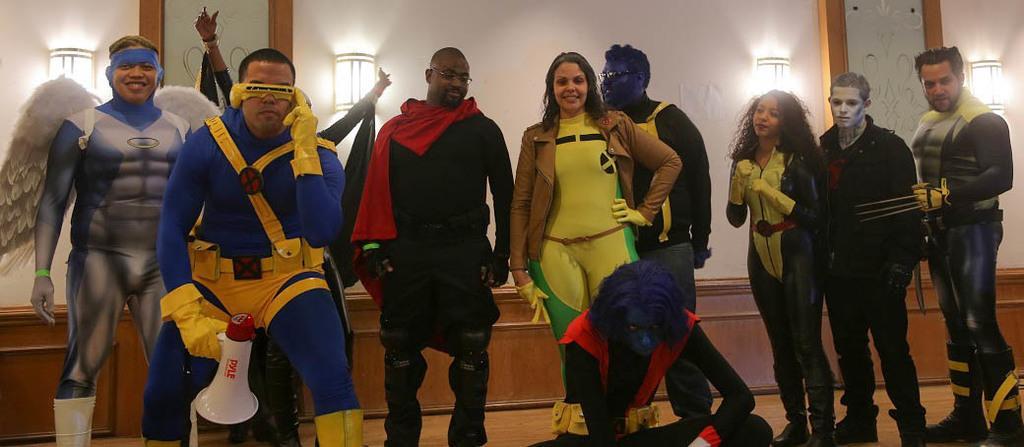How would you summarize this image in a sentence or two? In this image we can see the people in the different costumes. And we can see the lights and the wall. 